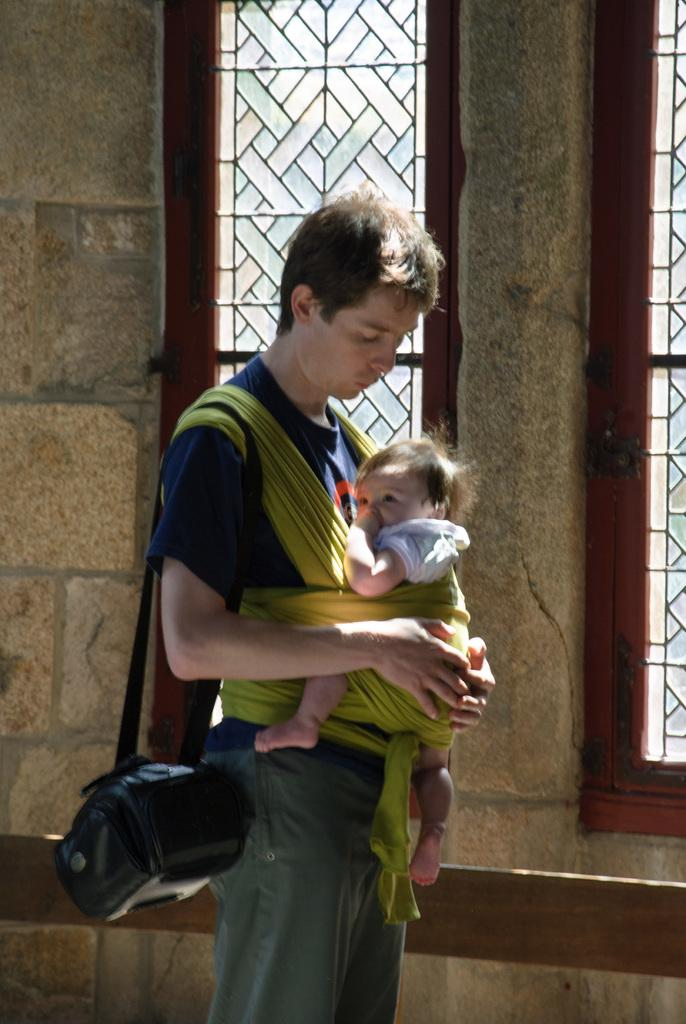Who is present in the image? There is a person and a baby in the image. What can be seen in the background of the image? There is a wall and windows in the background of the image. What type of sweater is the person wearing in the image? There is no information about the person's clothing in the image, so we cannot determine if they are wearing a sweater or not. 